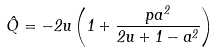<formula> <loc_0><loc_0><loc_500><loc_500>\hat { Q } = - 2 u \left ( 1 + \frac { p a ^ { 2 } } { 2 u + 1 - a ^ { 2 } } \right )</formula> 